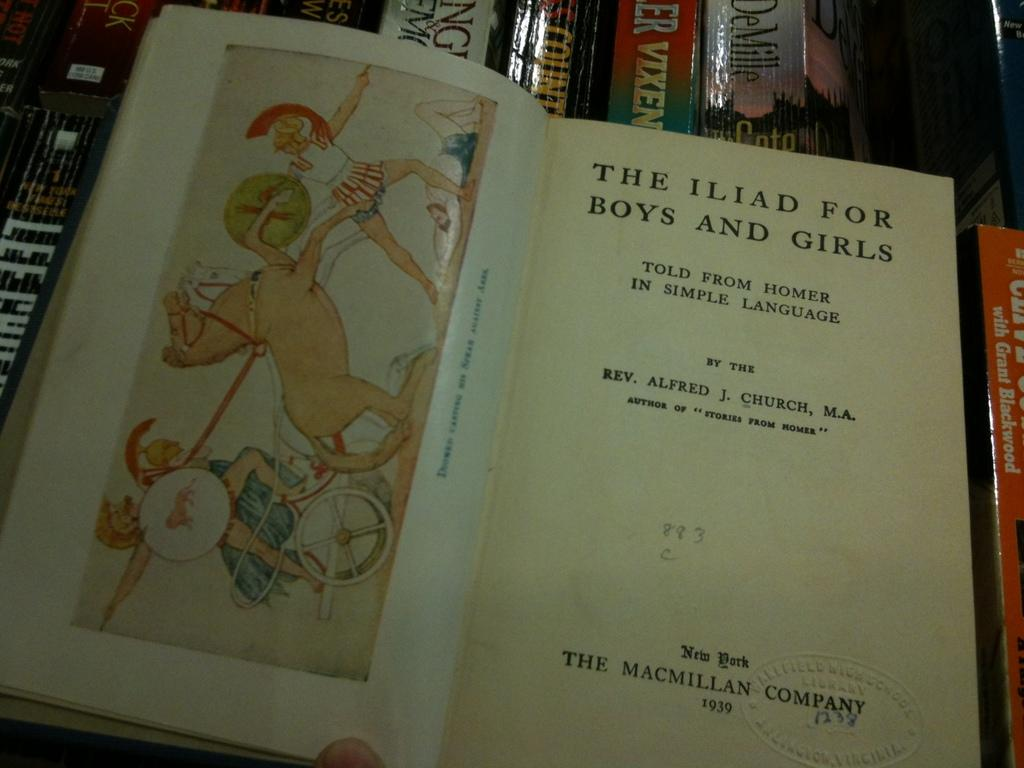<image>
Create a compact narrative representing the image presented. a book titled The Iliad for Boys and Girls open to the title page 